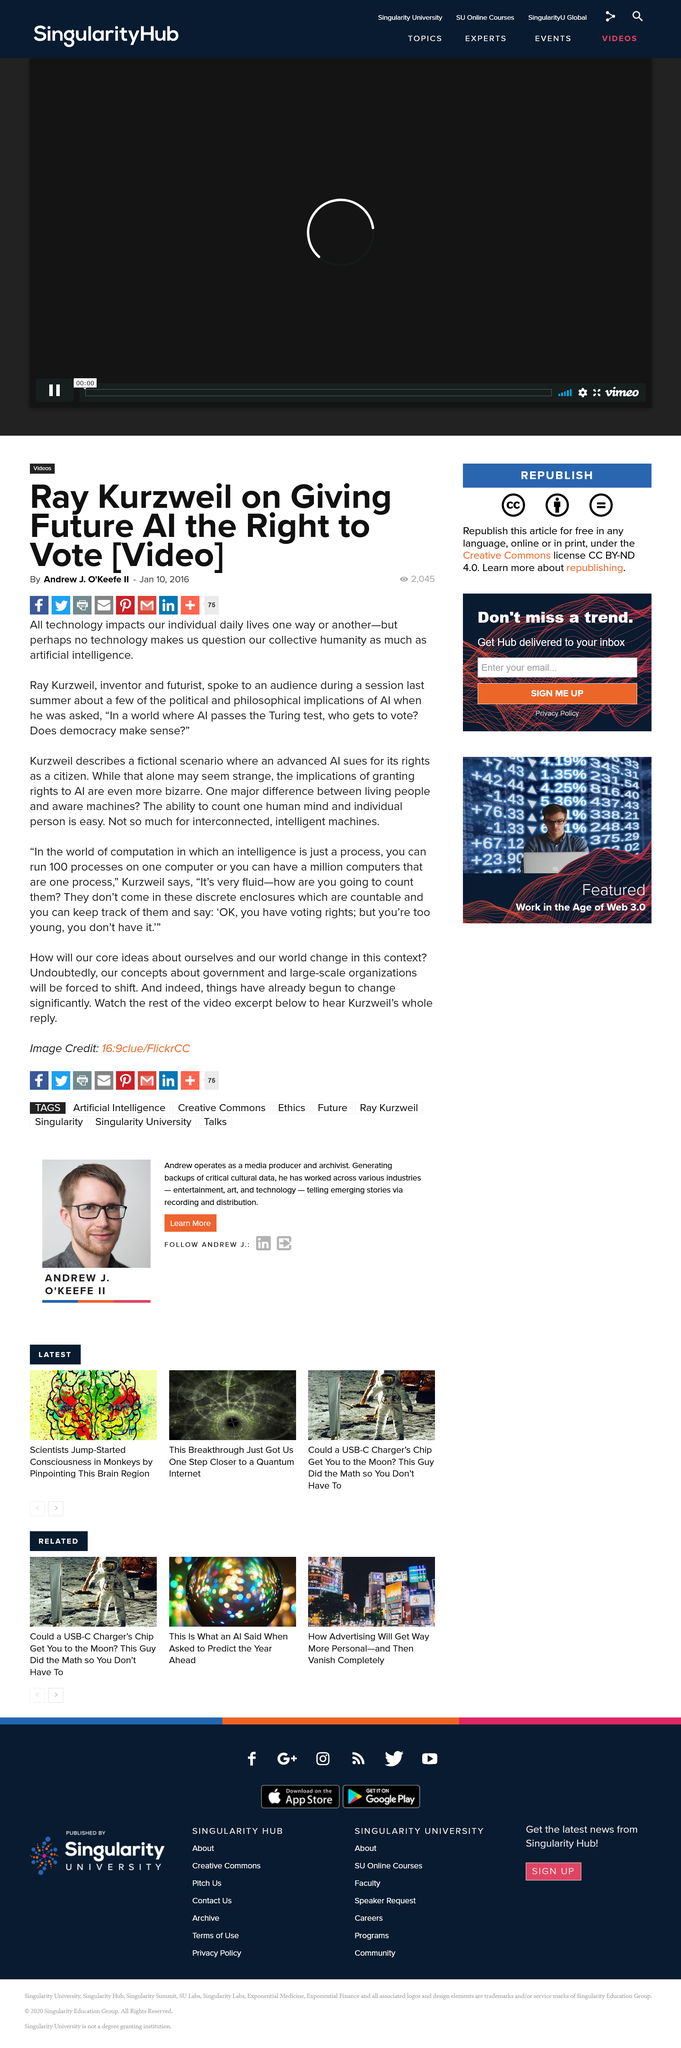Outline some significant characteristics in this image. It is undeniable that all technology has some impact on our daily lives, whether it be positive or negative. The article describing Ray Kurzweil describing a fictional scenario was written by Andrew J. O'Keefe II. Ray Kurzweil is an inventor and futurist who is recognized as such by many. 